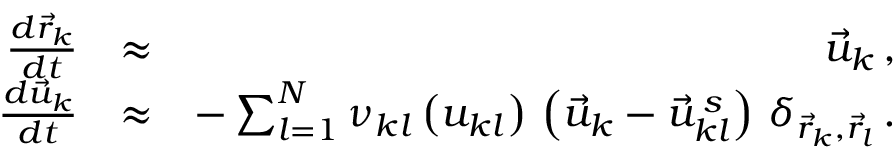Convert formula to latex. <formula><loc_0><loc_0><loc_500><loc_500>\begin{array} { r l r } { \frac { d \vec { r } _ { k } } { d t } } & { \approx } & { \vec { u } _ { k } \, , } \\ { \frac { d \vec { u } _ { k } } { d t } } & { \approx } & { - \sum _ { l = 1 } ^ { N } \nu _ { k l } \left ( u _ { k l } \right ) \, \left ( \vec { u } _ { k } - \vec { u } _ { k l } ^ { \, s } \right ) \, \delta _ { \vec { r } _ { k } , \vec { r } _ { l } } \, . } \end{array}</formula> 